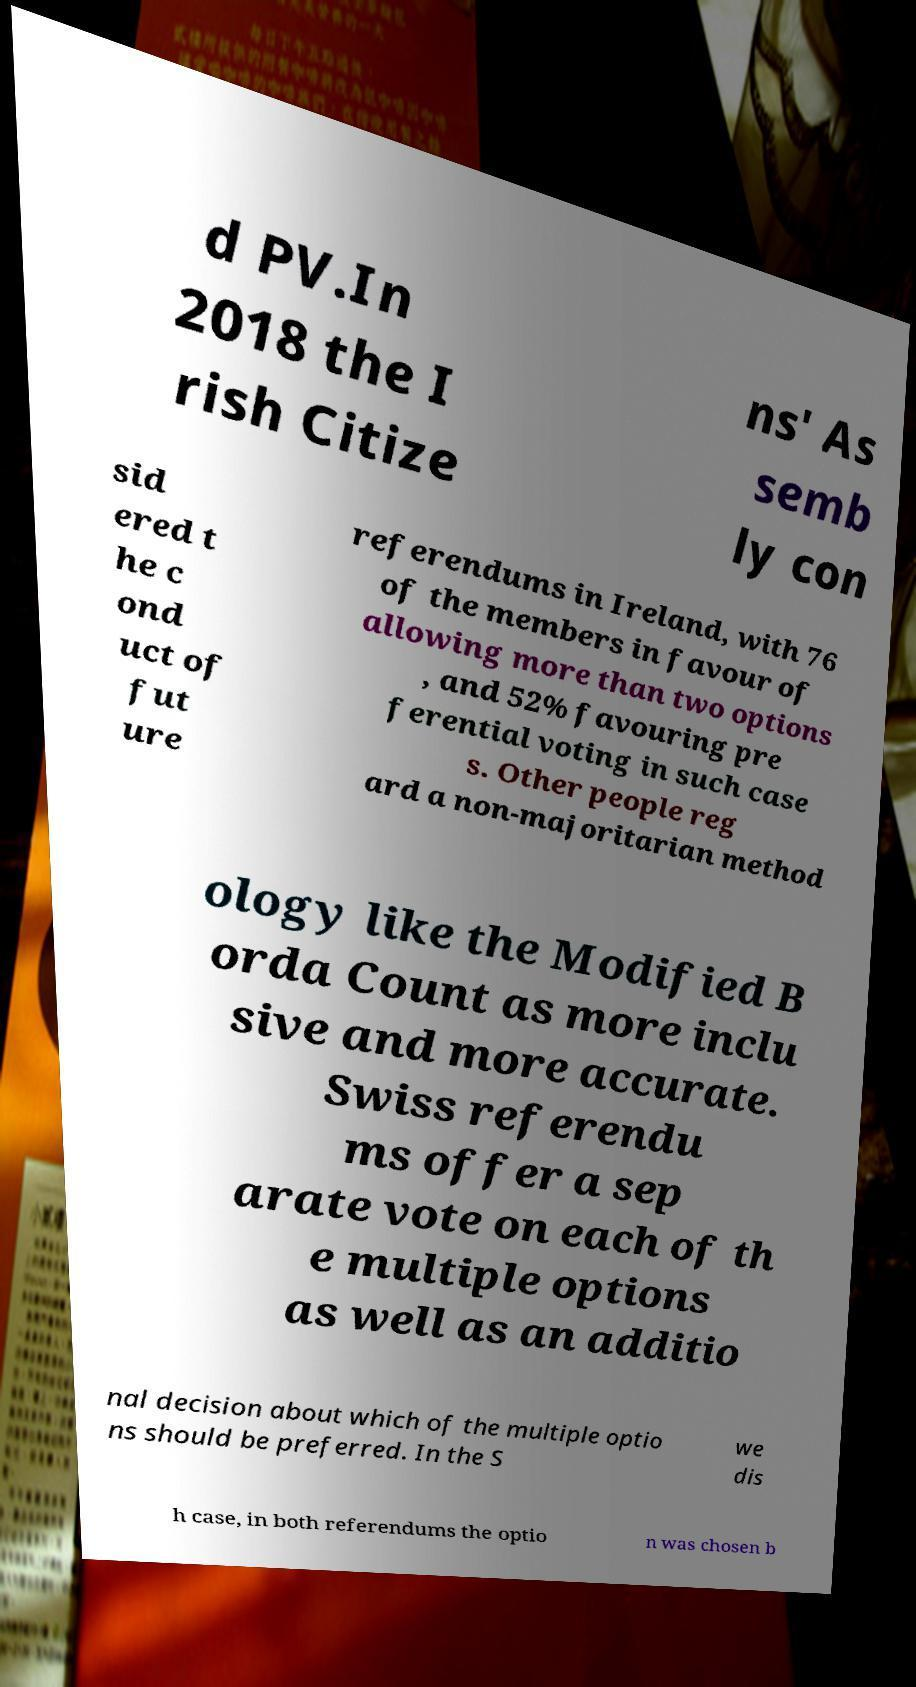Could you extract and type out the text from this image? d PV.In 2018 the I rish Citize ns' As semb ly con sid ered t he c ond uct of fut ure referendums in Ireland, with 76 of the members in favour of allowing more than two options , and 52% favouring pre ferential voting in such case s. Other people reg ard a non-majoritarian method ology like the Modified B orda Count as more inclu sive and more accurate. Swiss referendu ms offer a sep arate vote on each of th e multiple options as well as an additio nal decision about which of the multiple optio ns should be preferred. In the S we dis h case, in both referendums the optio n was chosen b 